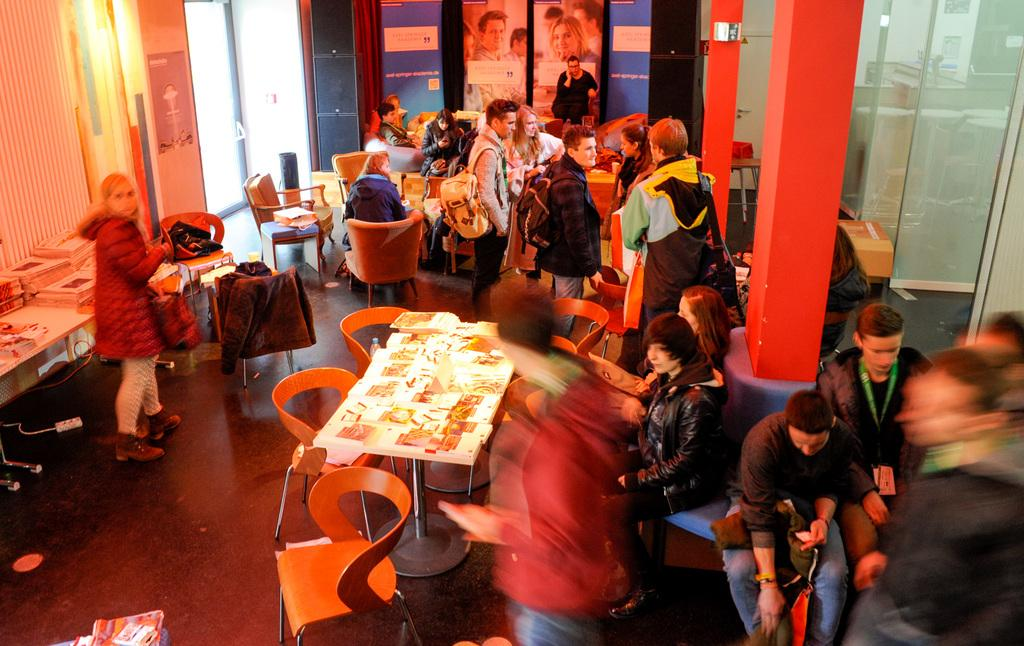How many individuals are present in the room? There are many people in the room. Can you describe the gender distribution of the people in the room? Some of the people are women, and some are men. What are some of the people doing in the room? Some people are sitting in chairs, and a man is walking with something in his hand. How many lines are visible on the floor in the image? There is no mention of lines on the floor in the image, so it is not possible to answer that question. 